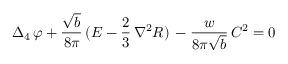Convert formula to latex. <formula><loc_0><loc_0><loc_500><loc_500>\Delta _ { 4 } \, \varphi + \frac { \sqrt { b } } { 8 \pi } \, ( E - \frac { 2 } { 3 } \, { \nabla } ^ { 2 } R ) \, - \frac { w } { 8 \pi \sqrt { b } } \, C ^ { 2 } = 0</formula> 